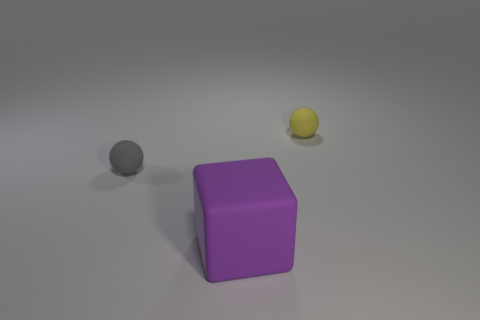There is a small thing that is behind the small thing on the left side of the cube; what shape is it?
Make the answer very short. Sphere. Is there any other thing that has the same color as the matte block?
Keep it short and to the point. No. There is a purple rubber cube; is its size the same as the yellow rubber object that is behind the gray ball?
Keep it short and to the point. No. How many small things are either gray things or green cubes?
Offer a terse response. 1. Is the number of tiny rubber balls greater than the number of tiny brown metallic things?
Your answer should be compact. Yes. There is a small sphere behind the tiny matte sphere that is to the left of the large purple object; what number of yellow matte things are in front of it?
Your response must be concise. 0. What is the shape of the large thing?
Make the answer very short. Cube. What number of other things are made of the same material as the yellow sphere?
Ensure brevity in your answer.  2. Is the size of the gray rubber sphere the same as the matte cube?
Your response must be concise. No. What shape is the rubber thing on the left side of the rubber cube?
Your answer should be compact. Sphere. 